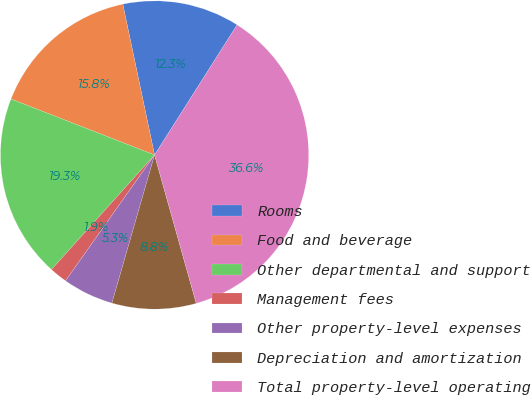Convert chart. <chart><loc_0><loc_0><loc_500><loc_500><pie_chart><fcel>Rooms<fcel>Food and beverage<fcel>Other departmental and support<fcel>Management fees<fcel>Other property-level expenses<fcel>Depreciation and amortization<fcel>Total property-level operating<nl><fcel>12.3%<fcel>15.78%<fcel>19.26%<fcel>1.86%<fcel>5.34%<fcel>8.82%<fcel>36.65%<nl></chart> 